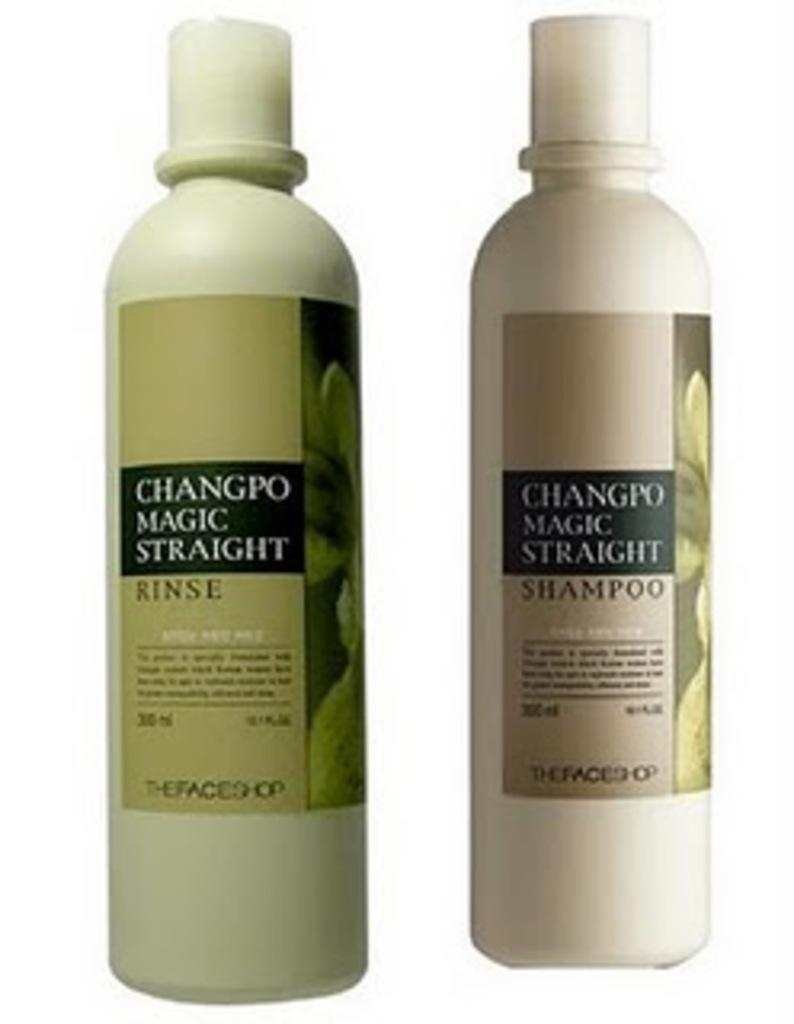<image>
Render a clear and concise summary of the photo. two bottles of changro magic straight shampoo and rinse. 